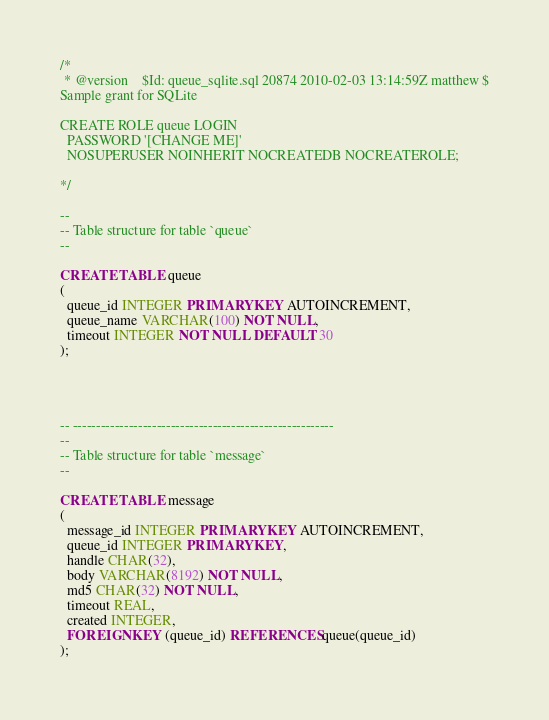<code> <loc_0><loc_0><loc_500><loc_500><_SQL_>/*
 * @version    $Id: queue_sqlite.sql 20874 2010-02-03 13:14:59Z matthew $
Sample grant for SQLite

CREATE ROLE queue LOGIN
  PASSWORD '[CHANGE ME]'
  NOSUPERUSER NOINHERIT NOCREATEDB NOCREATEROLE;

*/

--
-- Table structure for table `queue`
--

CREATE TABLE queue
(
  queue_id INTEGER PRIMARY KEY AUTOINCREMENT,
  queue_name VARCHAR(100) NOT NULL,
  timeout INTEGER NOT NULL DEFAULT 30
);




-- --------------------------------------------------------
--
-- Table structure for table `message`
--

CREATE TABLE message
(
  message_id INTEGER PRIMARY KEY AUTOINCREMENT,
  queue_id INTEGER PRIMARY KEY,
  handle CHAR(32),
  body VARCHAR(8192) NOT NULL,
  md5 CHAR(32) NOT NULL,
  timeout REAL,
  created INTEGER,
  FOREIGN KEY (queue_id) REFERENCES queue(queue_id)
);

</code> 